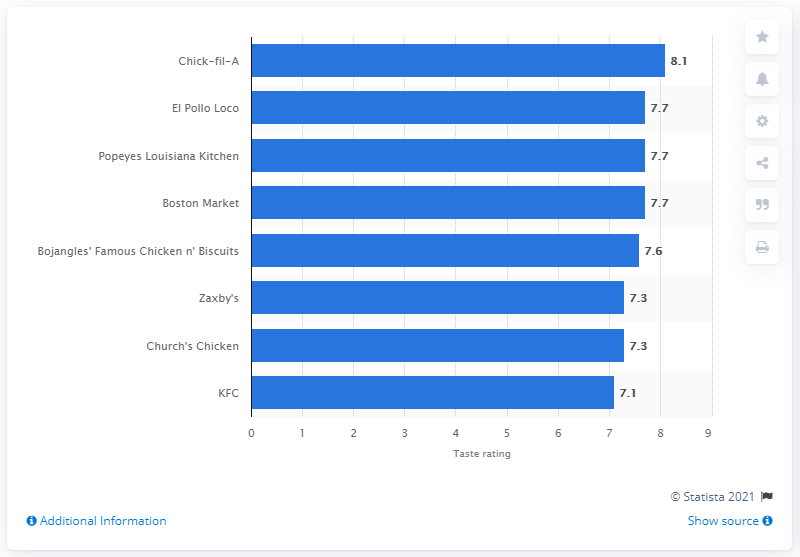Identify some key points in this picture. Popeyes Louisiana Kitchen is a chicken restaurant chain that has received a rating of 7.7 out of 10, making it a highly regarded establishment in the industry. Popeyes Louisiana Kitchen was given a rating of 7.7 by a certain source. 